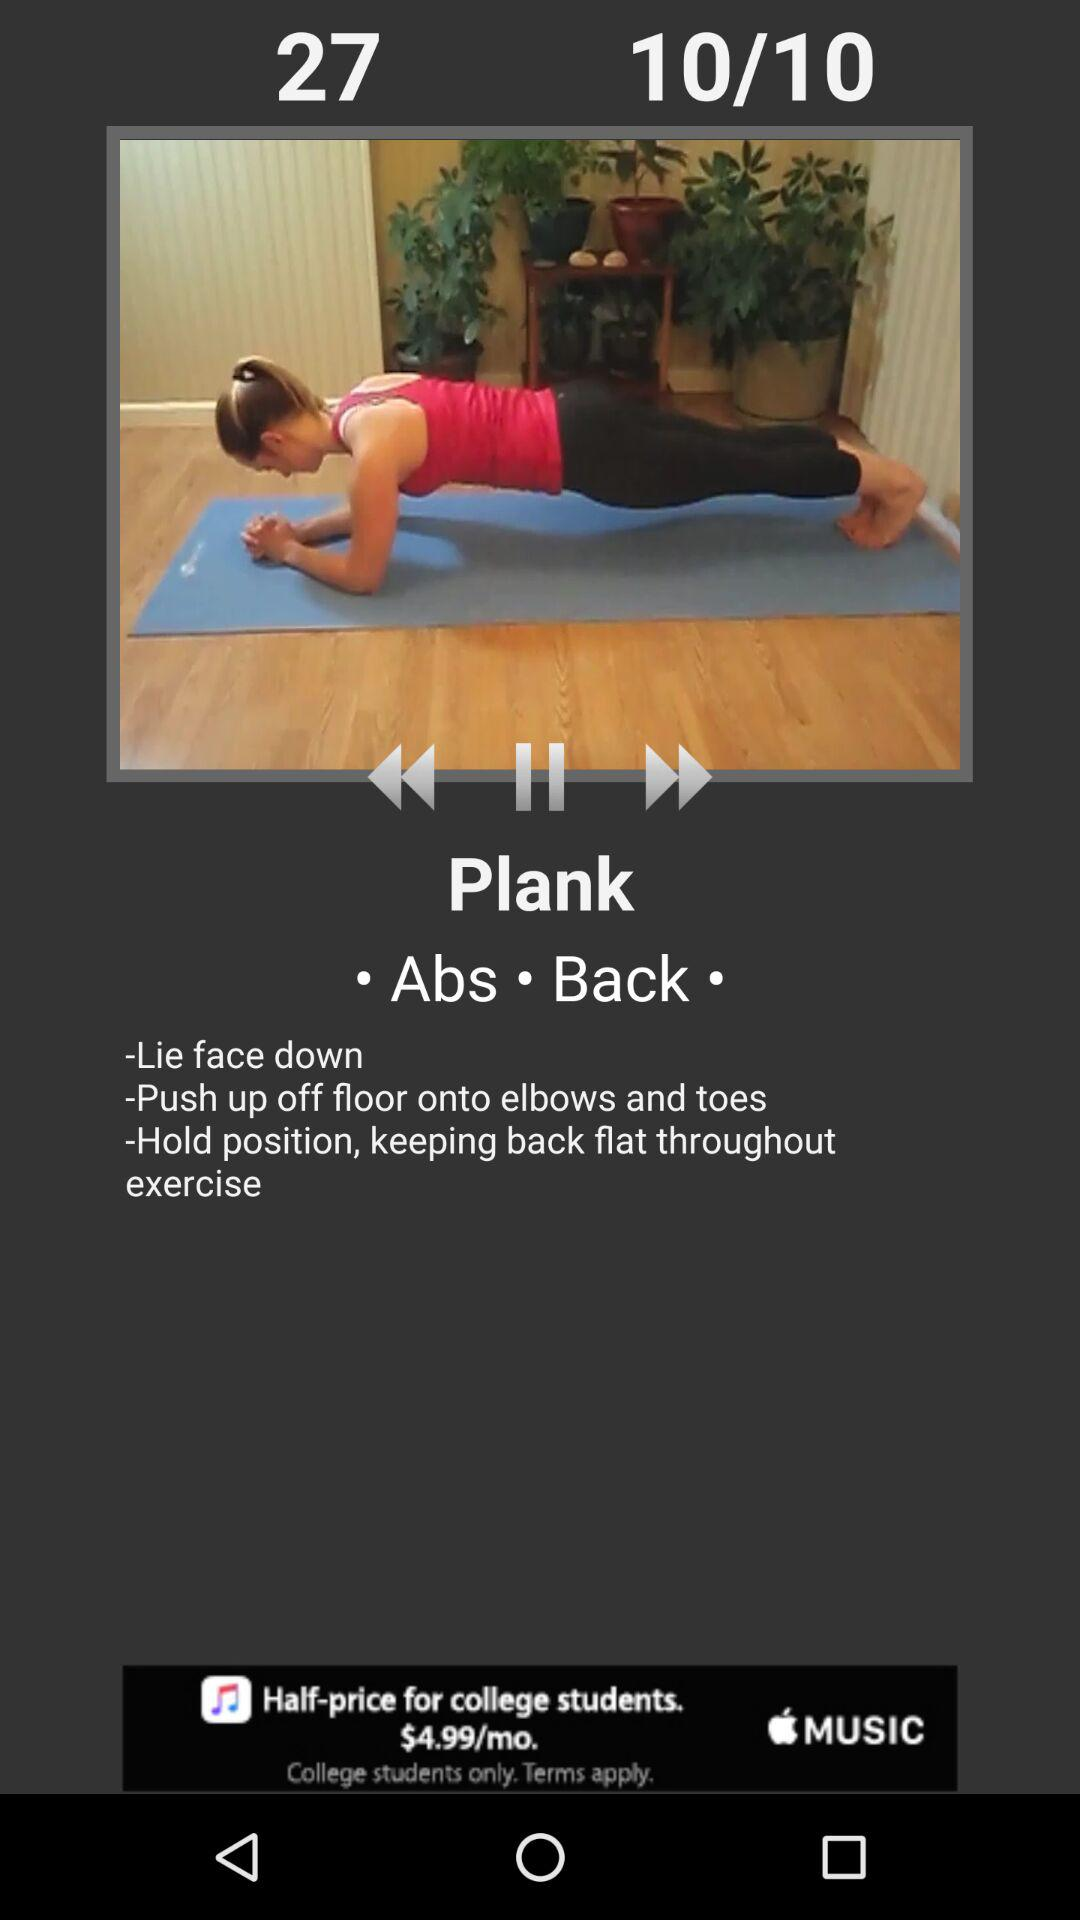How long does the user have to plank?
When the provided information is insufficient, respond with <no answer>. <no answer> 